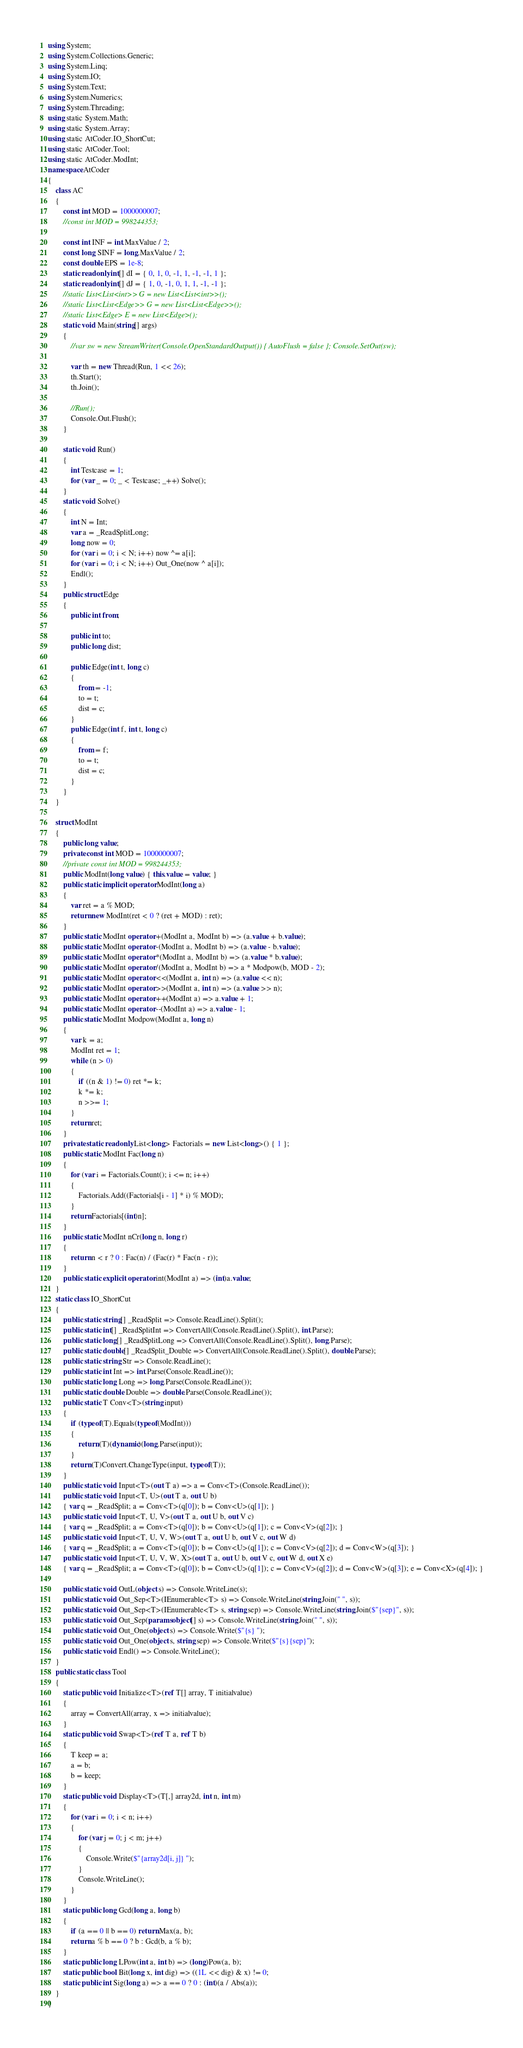<code> <loc_0><loc_0><loc_500><loc_500><_C#_>using System;
using System.Collections.Generic;
using System.Linq;
using System.IO;
using System.Text;
using System.Numerics;
using System.Threading;
using static System.Math;
using static System.Array;
using static AtCoder.IO_ShortCut;
using static AtCoder.Tool;
using static AtCoder.ModInt;
namespace AtCoder
{
    class AC
    {
        const int MOD = 1000000007;
        //const int MOD = 998244353;

        const int INF = int.MaxValue / 2;
        const long SINF = long.MaxValue / 2;
        const double EPS = 1e-8;
        static readonly int[] dI = { 0, 1, 0, -1, 1, -1, -1, 1 };
        static readonly int[] dJ = { 1, 0, -1, 0, 1, 1, -1, -1 };
        //static List<List<int>> G = new List<List<int>>();
        //static List<List<Edge>> G = new List<List<Edge>>();
        //static List<Edge> E = new List<Edge>();
        static void Main(string[] args)
        {
            //var sw = new StreamWriter(Console.OpenStandardOutput()) { AutoFlush = false }; Console.SetOut(sw);

            var th = new Thread(Run, 1 << 26);
            th.Start();
            th.Join();

            //Run();
            Console.Out.Flush();
        }

        static void Run()
        {
            int Testcase = 1;
            for (var _ = 0; _ < Testcase; _++) Solve();
        }
        static void Solve()
        {
            int N = Int;
            var a = _ReadSplitLong;
            long now = 0;
            for (var i = 0; i < N; i++) now ^= a[i];
            for (var i = 0; i < N; i++) Out_One(now ^ a[i]);
            Endl();
        }
        public struct Edge
        {
            public int from;

            public int to;
            public long dist;

            public Edge(int t, long c)
            {
                from = -1;
                to = t;
                dist = c;
            }
            public Edge(int f, int t, long c)
            {
                from = f;
                to = t;
                dist = c;
            }
        }
    }

    struct ModInt
    {
        public long value;
        private const int MOD = 1000000007;
        //private const int MOD = 998244353;
        public ModInt(long value) { this.value = value; }
        public static implicit operator ModInt(long a)
        {
            var ret = a % MOD;
            return new ModInt(ret < 0 ? (ret + MOD) : ret);
        }
        public static ModInt operator +(ModInt a, ModInt b) => (a.value + b.value);
        public static ModInt operator -(ModInt a, ModInt b) => (a.value - b.value);
        public static ModInt operator *(ModInt a, ModInt b) => (a.value * b.value);
        public static ModInt operator /(ModInt a, ModInt b) => a * Modpow(b, MOD - 2);
        public static ModInt operator <<(ModInt a, int n) => (a.value << n);
        public static ModInt operator >>(ModInt a, int n) => (a.value >> n);
        public static ModInt operator ++(ModInt a) => a.value + 1;
        public static ModInt operator --(ModInt a) => a.value - 1;
        public static ModInt Modpow(ModInt a, long n)
        {
            var k = a;
            ModInt ret = 1;
            while (n > 0)
            {
                if ((n & 1) != 0) ret *= k;
                k *= k;
                n >>= 1;
            }
            return ret;
        }
        private static readonly List<long> Factorials = new List<long>() { 1 };
        public static ModInt Fac(long n)
        {
            for (var i = Factorials.Count(); i <= n; i++)
            {
                Factorials.Add((Factorials[i - 1] * i) % MOD);
            }
            return Factorials[(int)n];
        }
        public static ModInt nCr(long n, long r)
        {
            return n < r ? 0 : Fac(n) / (Fac(r) * Fac(n - r));
        }
        public static explicit operator int(ModInt a) => (int)a.value;
    }
    static class IO_ShortCut
    {
        public static string[] _ReadSplit => Console.ReadLine().Split();
        public static int[] _ReadSplitInt => ConvertAll(Console.ReadLine().Split(), int.Parse);
        public static long[] _ReadSplitLong => ConvertAll(Console.ReadLine().Split(), long.Parse);
        public static double[] _ReadSplit_Double => ConvertAll(Console.ReadLine().Split(), double.Parse);
        public static string Str => Console.ReadLine();
        public static int Int => int.Parse(Console.ReadLine());
        public static long Long => long.Parse(Console.ReadLine());
        public static double Double => double.Parse(Console.ReadLine());
        public static T Conv<T>(string input)
        {
            if (typeof(T).Equals(typeof(ModInt)))
            {
                return (T)(dynamic)(long.Parse(input));
            }
            return (T)Convert.ChangeType(input, typeof(T));
        }
        public static void Input<T>(out T a) => a = Conv<T>(Console.ReadLine());
        public static void Input<T, U>(out T a, out U b)
        { var q = _ReadSplit; a = Conv<T>(q[0]); b = Conv<U>(q[1]); }
        public static void Input<T, U, V>(out T a, out U b, out V c)
        { var q = _ReadSplit; a = Conv<T>(q[0]); b = Conv<U>(q[1]); c = Conv<V>(q[2]); }
        public static void Input<T, U, V, W>(out T a, out U b, out V c, out W d)
        { var q = _ReadSplit; a = Conv<T>(q[0]); b = Conv<U>(q[1]); c = Conv<V>(q[2]); d = Conv<W>(q[3]); }
        public static void Input<T, U, V, W, X>(out T a, out U b, out V c, out W d, out X e)
        { var q = _ReadSplit; a = Conv<T>(q[0]); b = Conv<U>(q[1]); c = Conv<V>(q[2]); d = Conv<W>(q[3]); e = Conv<X>(q[4]); }

        public static void OutL(object s) => Console.WriteLine(s);
        public static void Out_Sep<T>(IEnumerable<T> s) => Console.WriteLine(string.Join(" ", s));
        public static void Out_Sep<T>(IEnumerable<T> s, string sep) => Console.WriteLine(string.Join($"{sep}", s));
        public static void Out_Sep(params object[] s) => Console.WriteLine(string.Join(" ", s));
        public static void Out_One(object s) => Console.Write($"{s} ");
        public static void Out_One(object s, string sep) => Console.Write($"{s}{sep}");
        public static void Endl() => Console.WriteLine();
    }
    public static class Tool
    {
        static public void Initialize<T>(ref T[] array, T initialvalue)
        {
            array = ConvertAll(array, x => initialvalue);
        }
        static public void Swap<T>(ref T a, ref T b)
        {
            T keep = a;
            a = b;
            b = keep;
        }
        static public void Display<T>(T[,] array2d, int n, int m)
        {
            for (var i = 0; i < n; i++)
            {
                for (var j = 0; j < m; j++)
                {
                    Console.Write($"{array2d[i, j]} ");
                }
                Console.WriteLine();
            }
        }
        static public long Gcd(long a, long b)
        {
            if (a == 0 || b == 0) return Max(a, b);
            return a % b == 0 ? b : Gcd(b, a % b);
        }
        static public long LPow(int a, int b) => (long)Pow(a, b);
        static public bool Bit(long x, int dig) => ((1L << dig) & x) != 0;
        static public int Sig(long a) => a == 0 ? 0 : (int)(a / Abs(a));
    }
}
</code> 